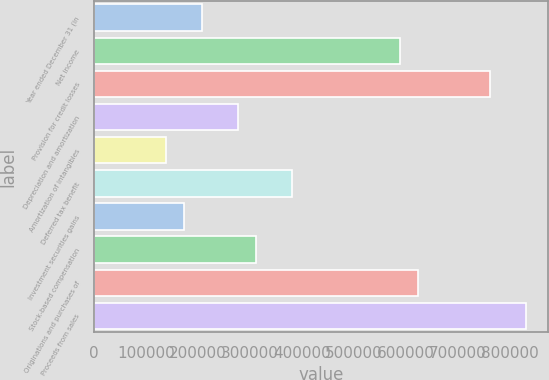Convert chart. <chart><loc_0><loc_0><loc_500><loc_500><bar_chart><fcel>Year ended December 31 (in<fcel>Net income<fcel>Provision for credit losses<fcel>Depreciation and amortization<fcel>Amortization of intangibles<fcel>Deferred tax benefit<fcel>Investment securities gains<fcel>Stock-based compensation<fcel>Originations and purchases of<fcel>Proceeds from sales<nl><fcel>207827<fcel>588826<fcel>762008<fcel>277099<fcel>138554<fcel>381008<fcel>173190<fcel>311736<fcel>623462<fcel>831280<nl></chart> 